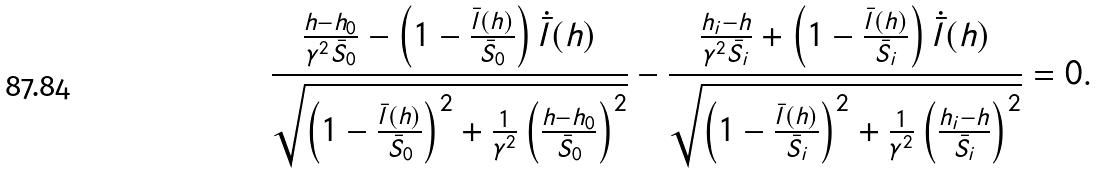<formula> <loc_0><loc_0><loc_500><loc_500>\frac { \frac { h - h _ { 0 } } { \gamma ^ { 2 } \bar { S } _ { 0 } } - \left ( 1 - \frac { \bar { l } ( h ) } { \bar { S } _ { 0 } } \right ) \dot { \bar { l } } ( h ) } { \sqrt { \left ( 1 - \frac { \bar { l } ( h ) } { \bar { S } _ { 0 } } \right ) ^ { 2 } + \frac { 1 } { \gamma ^ { 2 } } \left ( \frac { h - h _ { 0 } } { \bar { S } _ { 0 } } \right ) ^ { 2 } } } - \frac { \frac { h _ { i } - h } { \gamma ^ { 2 } \bar { S } _ { i } } + \left ( 1 - \frac { \bar { l } ( h ) } { \bar { S } _ { i } } \right ) \dot { \bar { l } } ( h ) } { \sqrt { \left ( 1 - \frac { \bar { l } ( h ) } { \bar { S } _ { i } } \right ) ^ { 2 } + \frac { 1 } { \gamma ^ { 2 } } \left ( \frac { h _ { i } - h } { \bar { S } _ { i } } \right ) ^ { 2 } } } = 0 .</formula> 